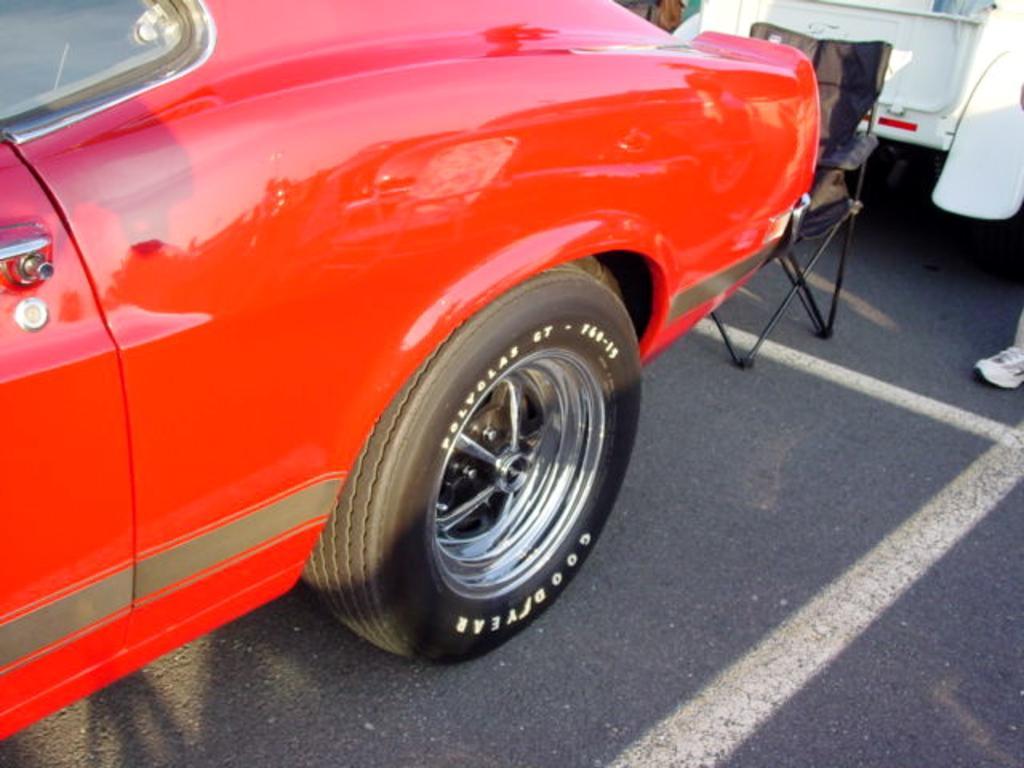Can you describe this image briefly? Here in this picture we can see a red and a white colored cars present on the road and in between that we can see a chair present and on the right side we can see a person's leg also present. 